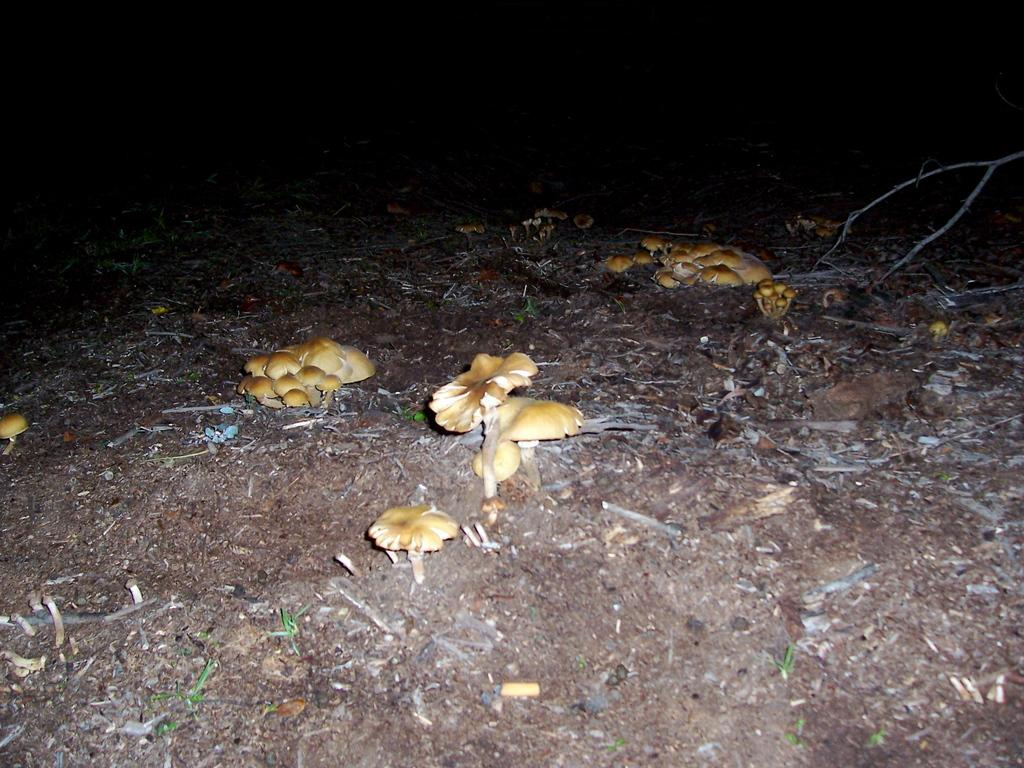What type of fungi can be seen in the image? There are mushrooms in the image. What is the color of the mushrooms? The mushrooms are brown in color. Where are the mushrooms located in the image? The mushrooms are on the ground. What can be seen in the background of the image? The background of the image is dark. What else is present in the image besides the mushrooms? Stocks are visible in the image. What type of fruit can be seen hanging from the stocks in the image? There is no fruit visible in the image; only mushrooms and stocks are present. 